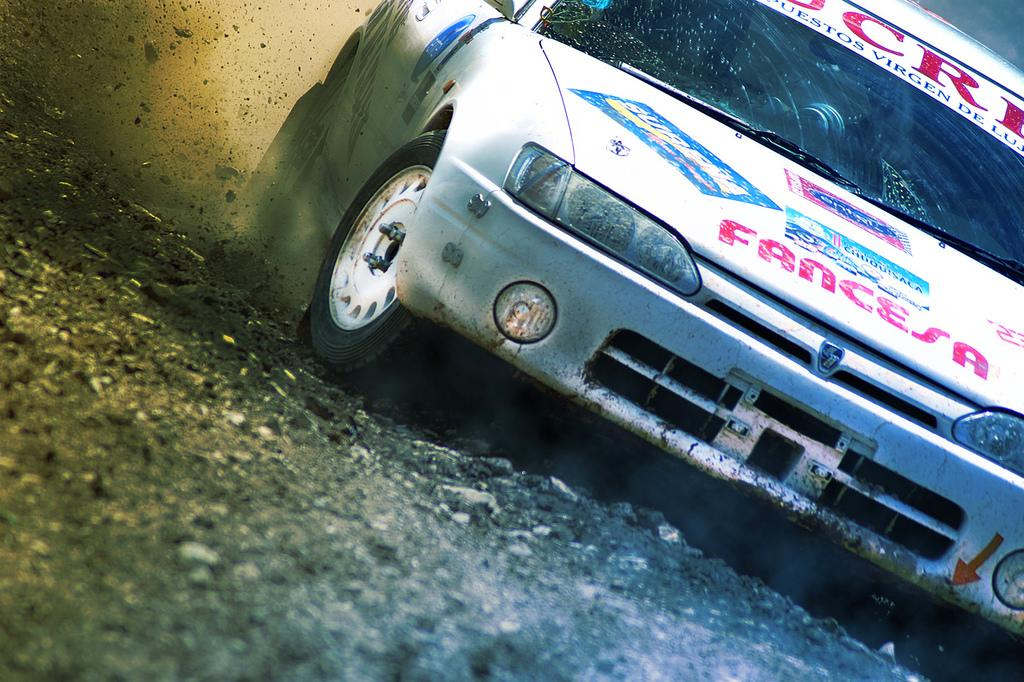What type of vehicle is in the image? There is a white car in the image. What is written or displayed on the car? There is text on the car. What is the surface beneath the car in the image? There is a ground at the bottom of the image. What can be seen in the air on the left side of the image? Dust is visible in the air on the left side of the image. What type of lumber is being used to build the structure in the image? There is no structure or lumber present in the image; it features a white car with text on it, a ground, and dust in the air. 